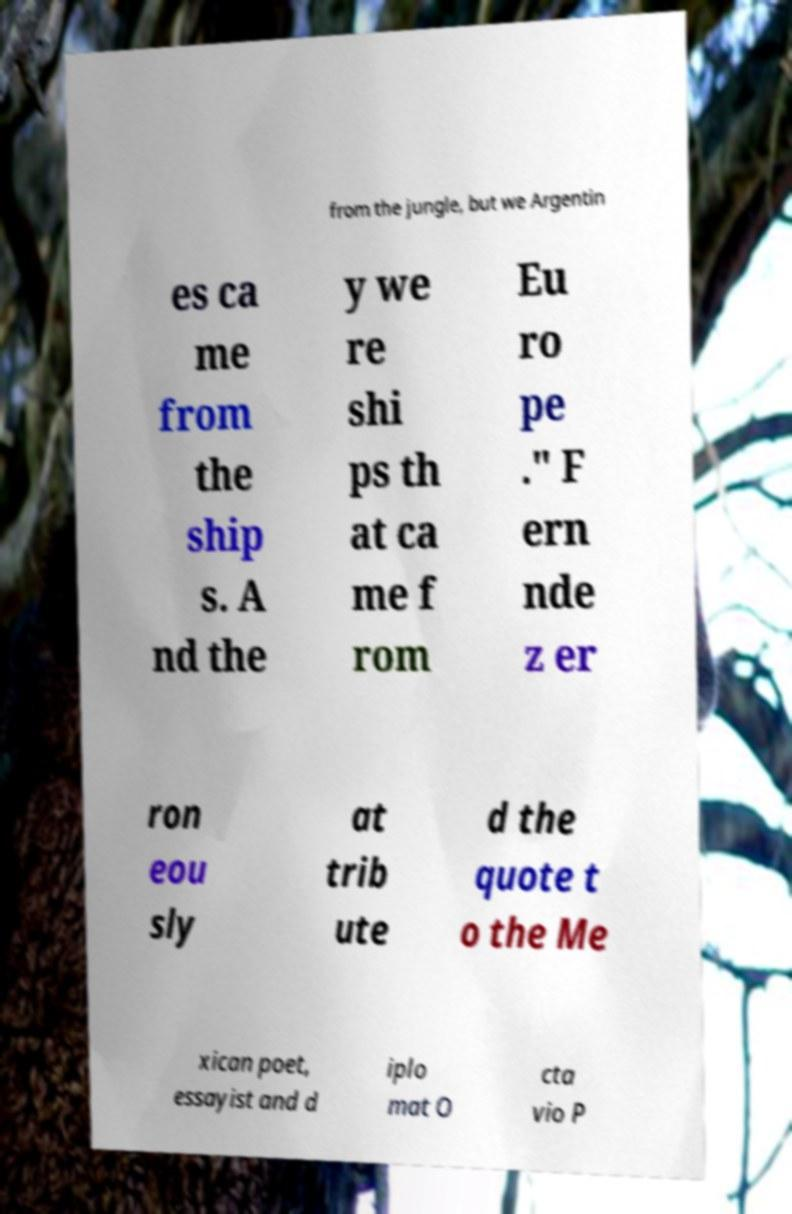What messages or text are displayed in this image? I need them in a readable, typed format. from the jungle, but we Argentin es ca me from the ship s. A nd the y we re shi ps th at ca me f rom Eu ro pe ." F ern nde z er ron eou sly at trib ute d the quote t o the Me xican poet, essayist and d iplo mat O cta vio P 